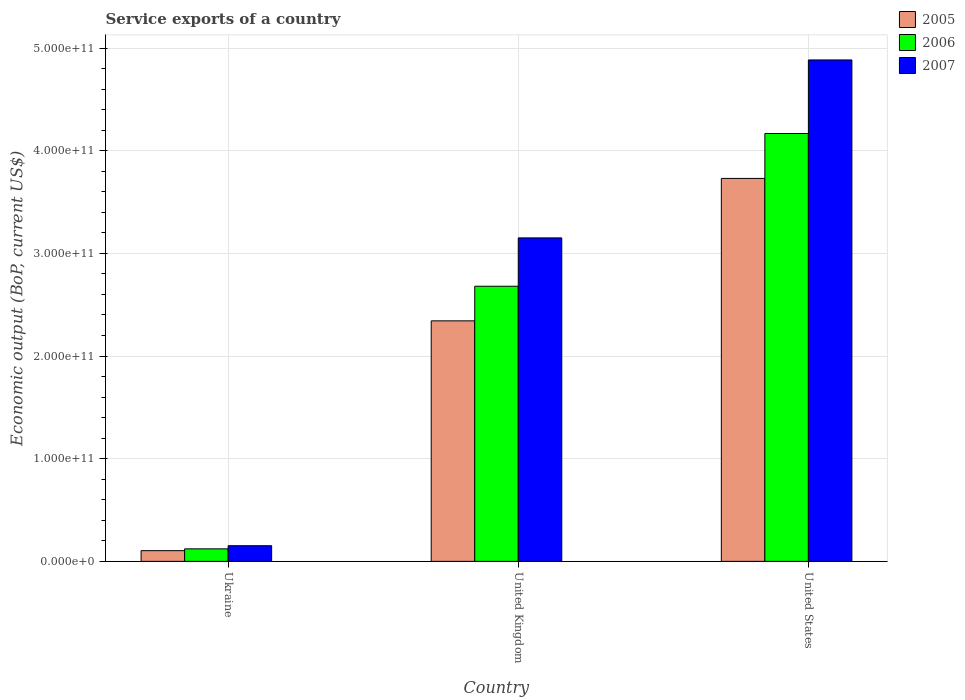How many different coloured bars are there?
Offer a very short reply. 3. How many groups of bars are there?
Give a very brief answer. 3. Are the number of bars per tick equal to the number of legend labels?
Ensure brevity in your answer.  Yes. Are the number of bars on each tick of the X-axis equal?
Offer a very short reply. Yes. In how many cases, is the number of bars for a given country not equal to the number of legend labels?
Your response must be concise. 0. What is the service exports in 2006 in United Kingdom?
Your response must be concise. 2.68e+11. Across all countries, what is the maximum service exports in 2006?
Provide a short and direct response. 4.17e+11. Across all countries, what is the minimum service exports in 2007?
Your answer should be compact. 1.52e+1. In which country was the service exports in 2006 maximum?
Your answer should be compact. United States. In which country was the service exports in 2006 minimum?
Give a very brief answer. Ukraine. What is the total service exports in 2006 in the graph?
Make the answer very short. 6.97e+11. What is the difference between the service exports in 2007 in United Kingdom and that in United States?
Offer a terse response. -1.73e+11. What is the difference between the service exports in 2007 in United States and the service exports in 2006 in Ukraine?
Your answer should be compact. 4.76e+11. What is the average service exports in 2006 per country?
Provide a succinct answer. 2.32e+11. What is the difference between the service exports of/in 2007 and service exports of/in 2005 in United States?
Your answer should be very brief. 1.15e+11. In how many countries, is the service exports in 2007 greater than 300000000000 US$?
Your response must be concise. 2. What is the ratio of the service exports in 2005 in Ukraine to that in United States?
Provide a short and direct response. 0.03. Is the difference between the service exports in 2007 in Ukraine and United States greater than the difference between the service exports in 2005 in Ukraine and United States?
Offer a terse response. No. What is the difference between the highest and the second highest service exports in 2006?
Provide a short and direct response. 1.49e+11. What is the difference between the highest and the lowest service exports in 2007?
Provide a short and direct response. 4.73e+11. What does the 1st bar from the right in United Kingdom represents?
Provide a succinct answer. 2007. How many bars are there?
Provide a short and direct response. 9. What is the difference between two consecutive major ticks on the Y-axis?
Give a very brief answer. 1.00e+11. Are the values on the major ticks of Y-axis written in scientific E-notation?
Offer a terse response. Yes. How are the legend labels stacked?
Your response must be concise. Vertical. What is the title of the graph?
Keep it short and to the point. Service exports of a country. Does "1964" appear as one of the legend labels in the graph?
Provide a short and direct response. No. What is the label or title of the Y-axis?
Your response must be concise. Economic output (BoP, current US$). What is the Economic output (BoP, current US$) of 2005 in Ukraine?
Ensure brevity in your answer.  1.04e+1. What is the Economic output (BoP, current US$) in 2006 in Ukraine?
Give a very brief answer. 1.22e+1. What is the Economic output (BoP, current US$) in 2007 in Ukraine?
Provide a succinct answer. 1.52e+1. What is the Economic output (BoP, current US$) of 2005 in United Kingdom?
Provide a succinct answer. 2.34e+11. What is the Economic output (BoP, current US$) of 2006 in United Kingdom?
Give a very brief answer. 2.68e+11. What is the Economic output (BoP, current US$) of 2007 in United Kingdom?
Offer a terse response. 3.15e+11. What is the Economic output (BoP, current US$) in 2005 in United States?
Your answer should be compact. 3.73e+11. What is the Economic output (BoP, current US$) of 2006 in United States?
Keep it short and to the point. 4.17e+11. What is the Economic output (BoP, current US$) of 2007 in United States?
Offer a very short reply. 4.88e+11. Across all countries, what is the maximum Economic output (BoP, current US$) of 2005?
Give a very brief answer. 3.73e+11. Across all countries, what is the maximum Economic output (BoP, current US$) in 2006?
Ensure brevity in your answer.  4.17e+11. Across all countries, what is the maximum Economic output (BoP, current US$) in 2007?
Give a very brief answer. 4.88e+11. Across all countries, what is the minimum Economic output (BoP, current US$) of 2005?
Offer a very short reply. 1.04e+1. Across all countries, what is the minimum Economic output (BoP, current US$) of 2006?
Provide a short and direct response. 1.22e+1. Across all countries, what is the minimum Economic output (BoP, current US$) in 2007?
Your answer should be very brief. 1.52e+1. What is the total Economic output (BoP, current US$) in 2005 in the graph?
Your answer should be very brief. 6.18e+11. What is the total Economic output (BoP, current US$) in 2006 in the graph?
Provide a succinct answer. 6.97e+11. What is the total Economic output (BoP, current US$) in 2007 in the graph?
Your response must be concise. 8.19e+11. What is the difference between the Economic output (BoP, current US$) in 2005 in Ukraine and that in United Kingdom?
Make the answer very short. -2.24e+11. What is the difference between the Economic output (BoP, current US$) of 2006 in Ukraine and that in United Kingdom?
Keep it short and to the point. -2.56e+11. What is the difference between the Economic output (BoP, current US$) of 2007 in Ukraine and that in United Kingdom?
Offer a very short reply. -3.00e+11. What is the difference between the Economic output (BoP, current US$) in 2005 in Ukraine and that in United States?
Provide a succinct answer. -3.63e+11. What is the difference between the Economic output (BoP, current US$) in 2006 in Ukraine and that in United States?
Provide a succinct answer. -4.05e+11. What is the difference between the Economic output (BoP, current US$) in 2007 in Ukraine and that in United States?
Provide a succinct answer. -4.73e+11. What is the difference between the Economic output (BoP, current US$) of 2005 in United Kingdom and that in United States?
Provide a succinct answer. -1.39e+11. What is the difference between the Economic output (BoP, current US$) in 2006 in United Kingdom and that in United States?
Your response must be concise. -1.49e+11. What is the difference between the Economic output (BoP, current US$) in 2007 in United Kingdom and that in United States?
Keep it short and to the point. -1.73e+11. What is the difference between the Economic output (BoP, current US$) in 2005 in Ukraine and the Economic output (BoP, current US$) in 2006 in United Kingdom?
Make the answer very short. -2.58e+11. What is the difference between the Economic output (BoP, current US$) of 2005 in Ukraine and the Economic output (BoP, current US$) of 2007 in United Kingdom?
Provide a succinct answer. -3.05e+11. What is the difference between the Economic output (BoP, current US$) in 2006 in Ukraine and the Economic output (BoP, current US$) in 2007 in United Kingdom?
Make the answer very short. -3.03e+11. What is the difference between the Economic output (BoP, current US$) in 2005 in Ukraine and the Economic output (BoP, current US$) in 2006 in United States?
Your answer should be compact. -4.06e+11. What is the difference between the Economic output (BoP, current US$) of 2005 in Ukraine and the Economic output (BoP, current US$) of 2007 in United States?
Give a very brief answer. -4.78e+11. What is the difference between the Economic output (BoP, current US$) of 2006 in Ukraine and the Economic output (BoP, current US$) of 2007 in United States?
Your response must be concise. -4.76e+11. What is the difference between the Economic output (BoP, current US$) in 2005 in United Kingdom and the Economic output (BoP, current US$) in 2006 in United States?
Your answer should be very brief. -1.82e+11. What is the difference between the Economic output (BoP, current US$) of 2005 in United Kingdom and the Economic output (BoP, current US$) of 2007 in United States?
Keep it short and to the point. -2.54e+11. What is the difference between the Economic output (BoP, current US$) of 2006 in United Kingdom and the Economic output (BoP, current US$) of 2007 in United States?
Provide a short and direct response. -2.20e+11. What is the average Economic output (BoP, current US$) in 2005 per country?
Give a very brief answer. 2.06e+11. What is the average Economic output (BoP, current US$) in 2006 per country?
Give a very brief answer. 2.32e+11. What is the average Economic output (BoP, current US$) in 2007 per country?
Provide a short and direct response. 2.73e+11. What is the difference between the Economic output (BoP, current US$) of 2005 and Economic output (BoP, current US$) of 2006 in Ukraine?
Provide a succinct answer. -1.74e+09. What is the difference between the Economic output (BoP, current US$) in 2005 and Economic output (BoP, current US$) in 2007 in Ukraine?
Give a very brief answer. -4.80e+09. What is the difference between the Economic output (BoP, current US$) in 2006 and Economic output (BoP, current US$) in 2007 in Ukraine?
Your answer should be very brief. -3.06e+09. What is the difference between the Economic output (BoP, current US$) of 2005 and Economic output (BoP, current US$) of 2006 in United Kingdom?
Keep it short and to the point. -3.37e+1. What is the difference between the Economic output (BoP, current US$) of 2005 and Economic output (BoP, current US$) of 2007 in United Kingdom?
Provide a succinct answer. -8.08e+1. What is the difference between the Economic output (BoP, current US$) of 2006 and Economic output (BoP, current US$) of 2007 in United Kingdom?
Give a very brief answer. -4.71e+1. What is the difference between the Economic output (BoP, current US$) of 2005 and Economic output (BoP, current US$) of 2006 in United States?
Make the answer very short. -4.37e+1. What is the difference between the Economic output (BoP, current US$) of 2005 and Economic output (BoP, current US$) of 2007 in United States?
Offer a terse response. -1.15e+11. What is the difference between the Economic output (BoP, current US$) in 2006 and Economic output (BoP, current US$) in 2007 in United States?
Keep it short and to the point. -7.17e+1. What is the ratio of the Economic output (BoP, current US$) of 2005 in Ukraine to that in United Kingdom?
Provide a short and direct response. 0.04. What is the ratio of the Economic output (BoP, current US$) in 2006 in Ukraine to that in United Kingdom?
Keep it short and to the point. 0.05. What is the ratio of the Economic output (BoP, current US$) in 2007 in Ukraine to that in United Kingdom?
Your answer should be compact. 0.05. What is the ratio of the Economic output (BoP, current US$) of 2005 in Ukraine to that in United States?
Offer a very short reply. 0.03. What is the ratio of the Economic output (BoP, current US$) of 2006 in Ukraine to that in United States?
Keep it short and to the point. 0.03. What is the ratio of the Economic output (BoP, current US$) of 2007 in Ukraine to that in United States?
Your answer should be very brief. 0.03. What is the ratio of the Economic output (BoP, current US$) of 2005 in United Kingdom to that in United States?
Your answer should be compact. 0.63. What is the ratio of the Economic output (BoP, current US$) of 2006 in United Kingdom to that in United States?
Your response must be concise. 0.64. What is the ratio of the Economic output (BoP, current US$) in 2007 in United Kingdom to that in United States?
Keep it short and to the point. 0.65. What is the difference between the highest and the second highest Economic output (BoP, current US$) in 2005?
Make the answer very short. 1.39e+11. What is the difference between the highest and the second highest Economic output (BoP, current US$) in 2006?
Ensure brevity in your answer.  1.49e+11. What is the difference between the highest and the second highest Economic output (BoP, current US$) in 2007?
Your answer should be very brief. 1.73e+11. What is the difference between the highest and the lowest Economic output (BoP, current US$) in 2005?
Make the answer very short. 3.63e+11. What is the difference between the highest and the lowest Economic output (BoP, current US$) of 2006?
Your answer should be very brief. 4.05e+11. What is the difference between the highest and the lowest Economic output (BoP, current US$) of 2007?
Offer a very short reply. 4.73e+11. 